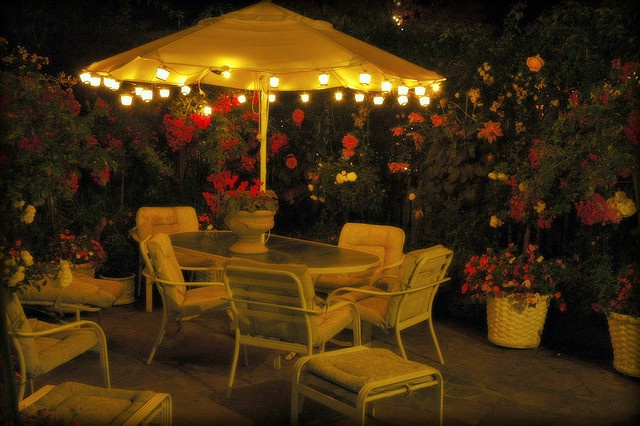Describe the objects in this image and their specific colors. I can see umbrella in black, olive, orange, gold, and maroon tones, potted plant in black, olive, and maroon tones, chair in black and olive tones, chair in black, olive, and maroon tones, and chair in black and olive tones in this image. 